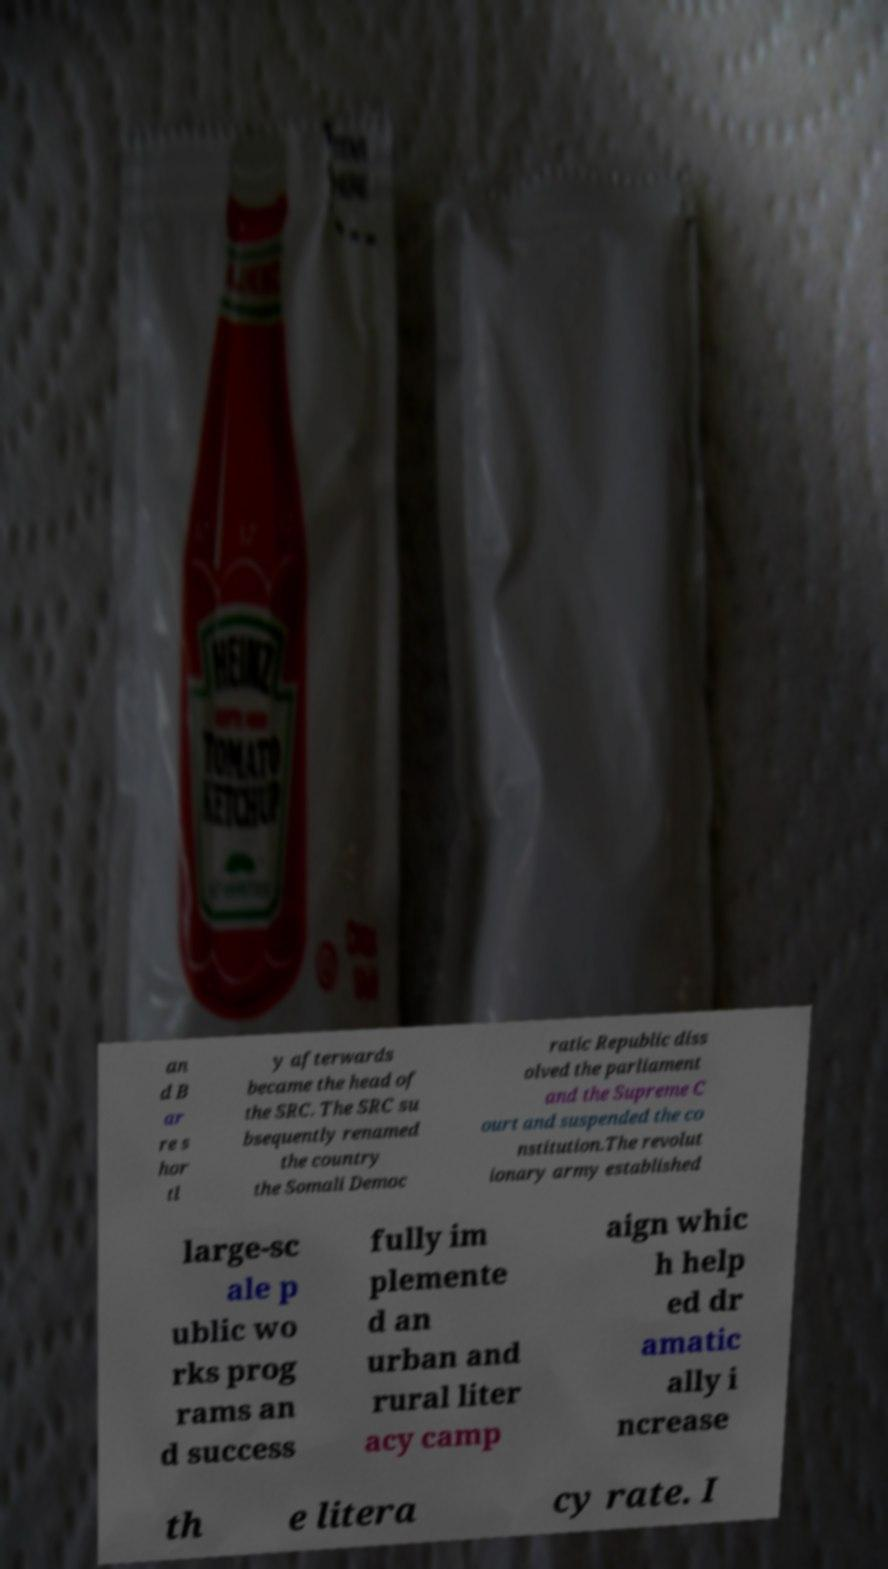Could you assist in decoding the text presented in this image and type it out clearly? an d B ar re s hor tl y afterwards became the head of the SRC. The SRC su bsequently renamed the country the Somali Democ ratic Republic diss olved the parliament and the Supreme C ourt and suspended the co nstitution.The revolut ionary army established large-sc ale p ublic wo rks prog rams an d success fully im plemente d an urban and rural liter acy camp aign whic h help ed dr amatic ally i ncrease th e litera cy rate. I 